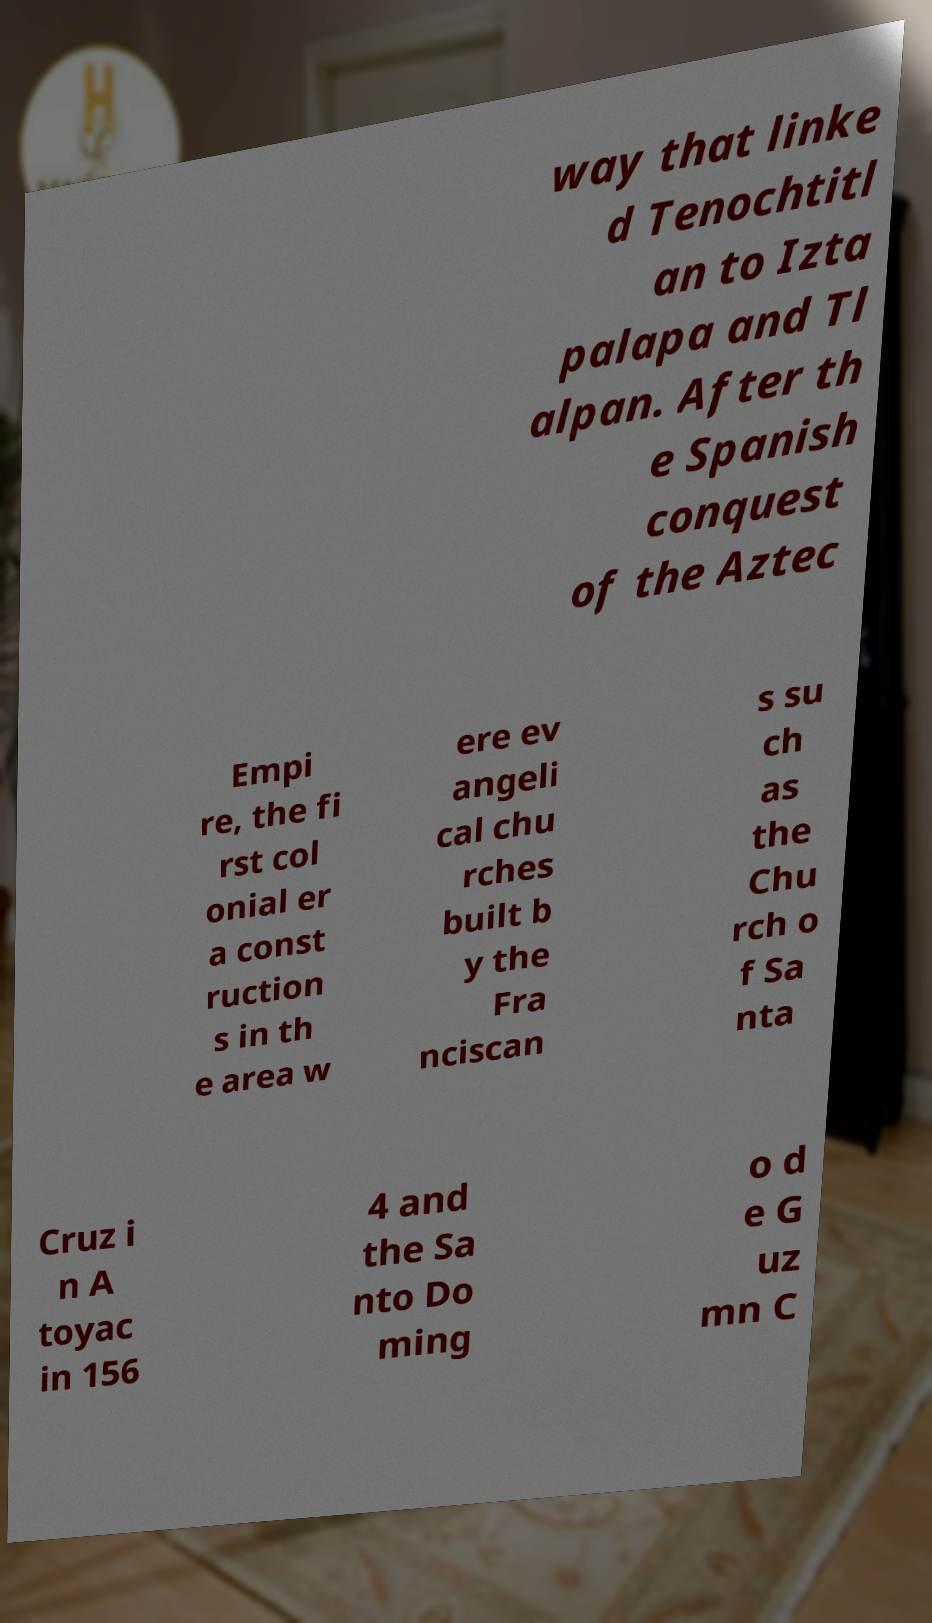Could you assist in decoding the text presented in this image and type it out clearly? way that linke d Tenochtitl an to Izta palapa and Tl alpan. After th e Spanish conquest of the Aztec Empi re, the fi rst col onial er a const ruction s in th e area w ere ev angeli cal chu rches built b y the Fra nciscan s su ch as the Chu rch o f Sa nta Cruz i n A toyac in 156 4 and the Sa nto Do ming o d e G uz mn C 